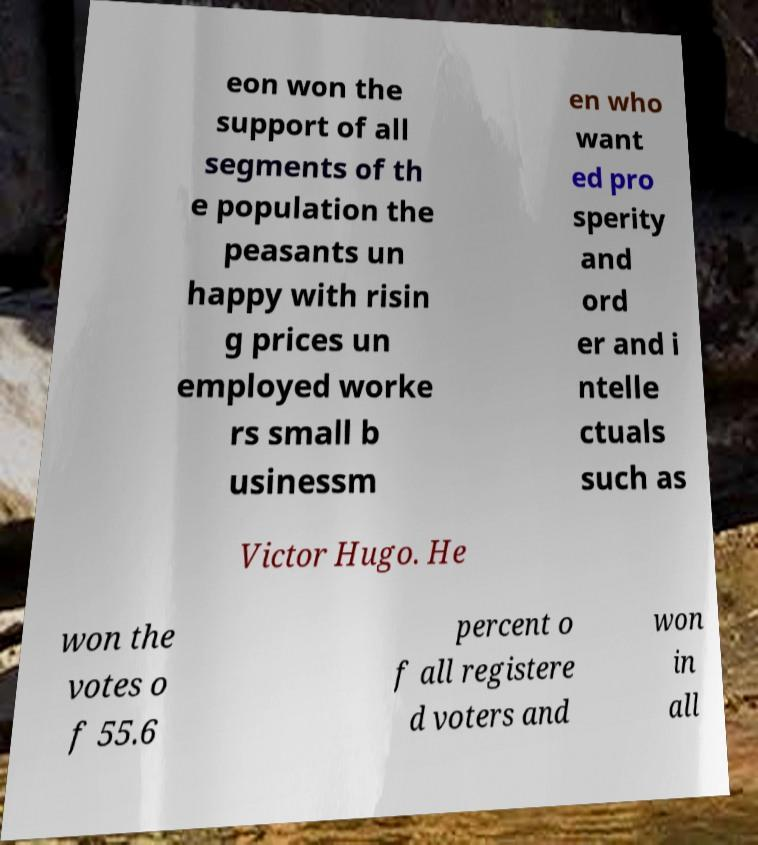Can you read and provide the text displayed in the image?This photo seems to have some interesting text. Can you extract and type it out for me? eon won the support of all segments of th e population the peasants un happy with risin g prices un employed worke rs small b usinessm en who want ed pro sperity and ord er and i ntelle ctuals such as Victor Hugo. He won the votes o f 55.6 percent o f all registere d voters and won in all 